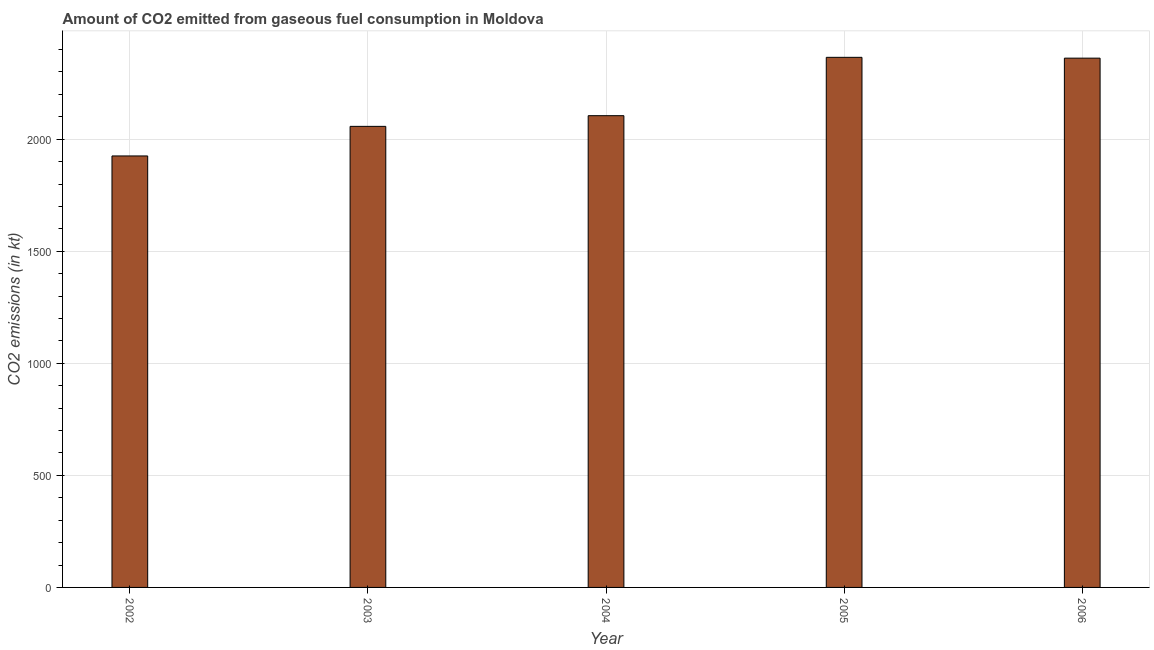Does the graph contain any zero values?
Keep it short and to the point. No. What is the title of the graph?
Provide a short and direct response. Amount of CO2 emitted from gaseous fuel consumption in Moldova. What is the label or title of the Y-axis?
Offer a terse response. CO2 emissions (in kt). What is the co2 emissions from gaseous fuel consumption in 2005?
Make the answer very short. 2365.22. Across all years, what is the maximum co2 emissions from gaseous fuel consumption?
Make the answer very short. 2365.22. Across all years, what is the minimum co2 emissions from gaseous fuel consumption?
Provide a succinct answer. 1925.17. In which year was the co2 emissions from gaseous fuel consumption minimum?
Your response must be concise. 2002. What is the sum of the co2 emissions from gaseous fuel consumption?
Your answer should be compact. 1.08e+04. What is the difference between the co2 emissions from gaseous fuel consumption in 2004 and 2006?
Your response must be concise. -256.69. What is the average co2 emissions from gaseous fuel consumption per year?
Your answer should be very brief. 2162.8. What is the median co2 emissions from gaseous fuel consumption?
Give a very brief answer. 2104.86. What is the ratio of the co2 emissions from gaseous fuel consumption in 2002 to that in 2005?
Keep it short and to the point. 0.81. What is the difference between the highest and the second highest co2 emissions from gaseous fuel consumption?
Give a very brief answer. 3.67. Is the sum of the co2 emissions from gaseous fuel consumption in 2004 and 2006 greater than the maximum co2 emissions from gaseous fuel consumption across all years?
Make the answer very short. Yes. What is the difference between the highest and the lowest co2 emissions from gaseous fuel consumption?
Ensure brevity in your answer.  440.04. In how many years, is the co2 emissions from gaseous fuel consumption greater than the average co2 emissions from gaseous fuel consumption taken over all years?
Provide a succinct answer. 2. Are the values on the major ticks of Y-axis written in scientific E-notation?
Make the answer very short. No. What is the CO2 emissions (in kt) of 2002?
Make the answer very short. 1925.17. What is the CO2 emissions (in kt) in 2003?
Make the answer very short. 2057.19. What is the CO2 emissions (in kt) of 2004?
Make the answer very short. 2104.86. What is the CO2 emissions (in kt) in 2005?
Keep it short and to the point. 2365.22. What is the CO2 emissions (in kt) of 2006?
Your answer should be compact. 2361.55. What is the difference between the CO2 emissions (in kt) in 2002 and 2003?
Keep it short and to the point. -132.01. What is the difference between the CO2 emissions (in kt) in 2002 and 2004?
Provide a short and direct response. -179.68. What is the difference between the CO2 emissions (in kt) in 2002 and 2005?
Give a very brief answer. -440.04. What is the difference between the CO2 emissions (in kt) in 2002 and 2006?
Offer a very short reply. -436.37. What is the difference between the CO2 emissions (in kt) in 2003 and 2004?
Make the answer very short. -47.67. What is the difference between the CO2 emissions (in kt) in 2003 and 2005?
Ensure brevity in your answer.  -308.03. What is the difference between the CO2 emissions (in kt) in 2003 and 2006?
Ensure brevity in your answer.  -304.36. What is the difference between the CO2 emissions (in kt) in 2004 and 2005?
Ensure brevity in your answer.  -260.36. What is the difference between the CO2 emissions (in kt) in 2004 and 2006?
Keep it short and to the point. -256.69. What is the difference between the CO2 emissions (in kt) in 2005 and 2006?
Provide a succinct answer. 3.67. What is the ratio of the CO2 emissions (in kt) in 2002 to that in 2003?
Offer a terse response. 0.94. What is the ratio of the CO2 emissions (in kt) in 2002 to that in 2004?
Keep it short and to the point. 0.92. What is the ratio of the CO2 emissions (in kt) in 2002 to that in 2005?
Offer a terse response. 0.81. What is the ratio of the CO2 emissions (in kt) in 2002 to that in 2006?
Give a very brief answer. 0.81. What is the ratio of the CO2 emissions (in kt) in 2003 to that in 2004?
Offer a very short reply. 0.98. What is the ratio of the CO2 emissions (in kt) in 2003 to that in 2005?
Provide a succinct answer. 0.87. What is the ratio of the CO2 emissions (in kt) in 2003 to that in 2006?
Your answer should be compact. 0.87. What is the ratio of the CO2 emissions (in kt) in 2004 to that in 2005?
Keep it short and to the point. 0.89. What is the ratio of the CO2 emissions (in kt) in 2004 to that in 2006?
Your answer should be very brief. 0.89. What is the ratio of the CO2 emissions (in kt) in 2005 to that in 2006?
Ensure brevity in your answer.  1. 